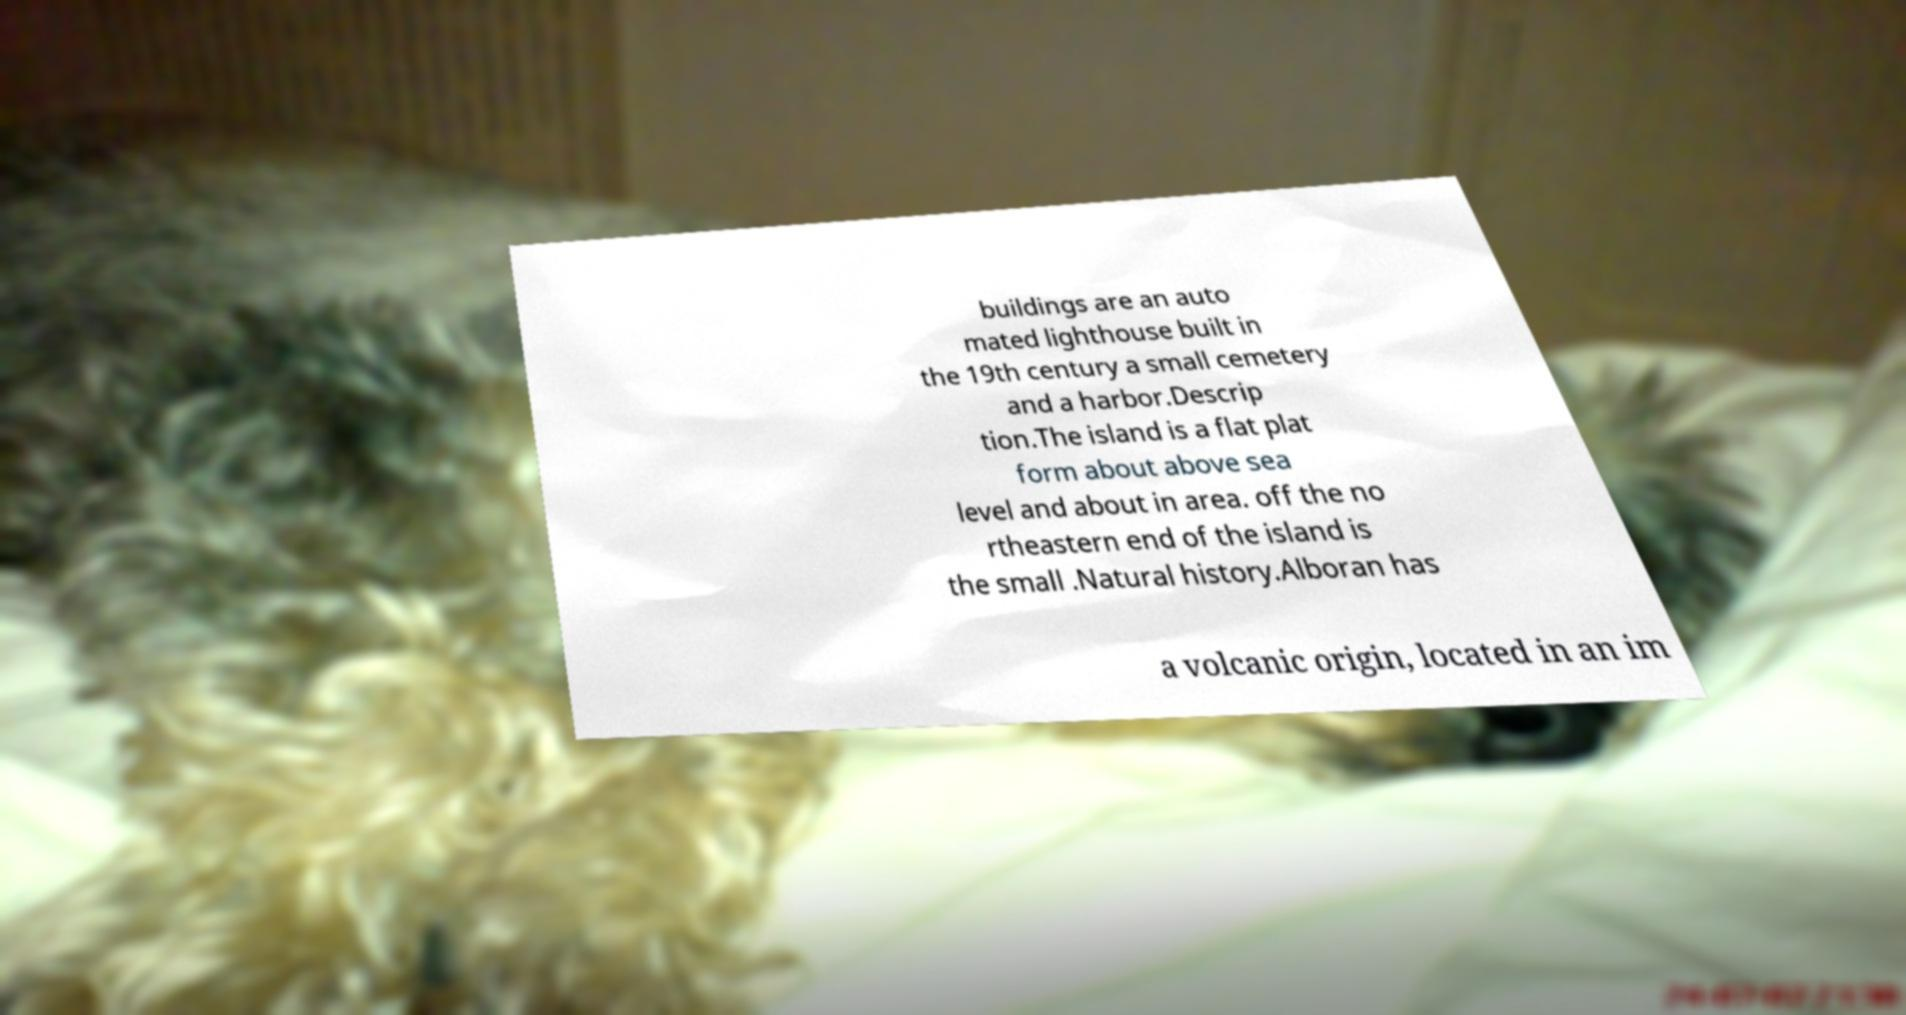Could you extract and type out the text from this image? buildings are an auto mated lighthouse built in the 19th century a small cemetery and a harbor.Descrip tion.The island is a flat plat form about above sea level and about in area. off the no rtheastern end of the island is the small .Natural history.Alboran has a volcanic origin, located in an im 